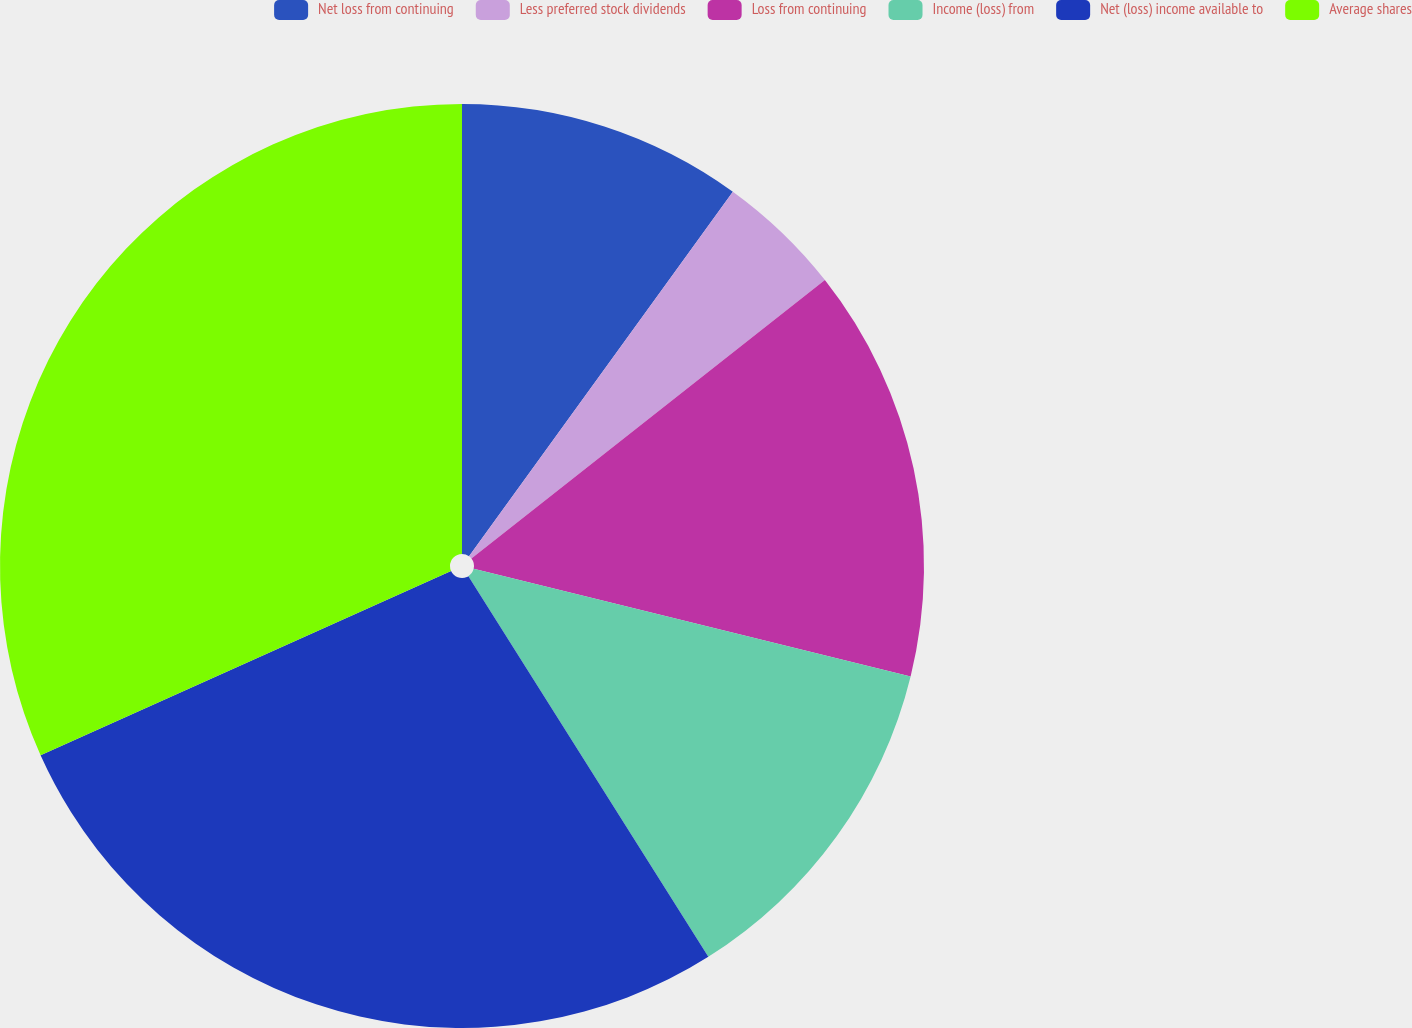<chart> <loc_0><loc_0><loc_500><loc_500><pie_chart><fcel>Net loss from continuing<fcel>Less preferred stock dividends<fcel>Loss from continuing<fcel>Income (loss) from<fcel>Net (loss) income available to<fcel>Average shares<nl><fcel>9.97%<fcel>4.41%<fcel>14.46%<fcel>12.21%<fcel>27.23%<fcel>31.72%<nl></chart> 